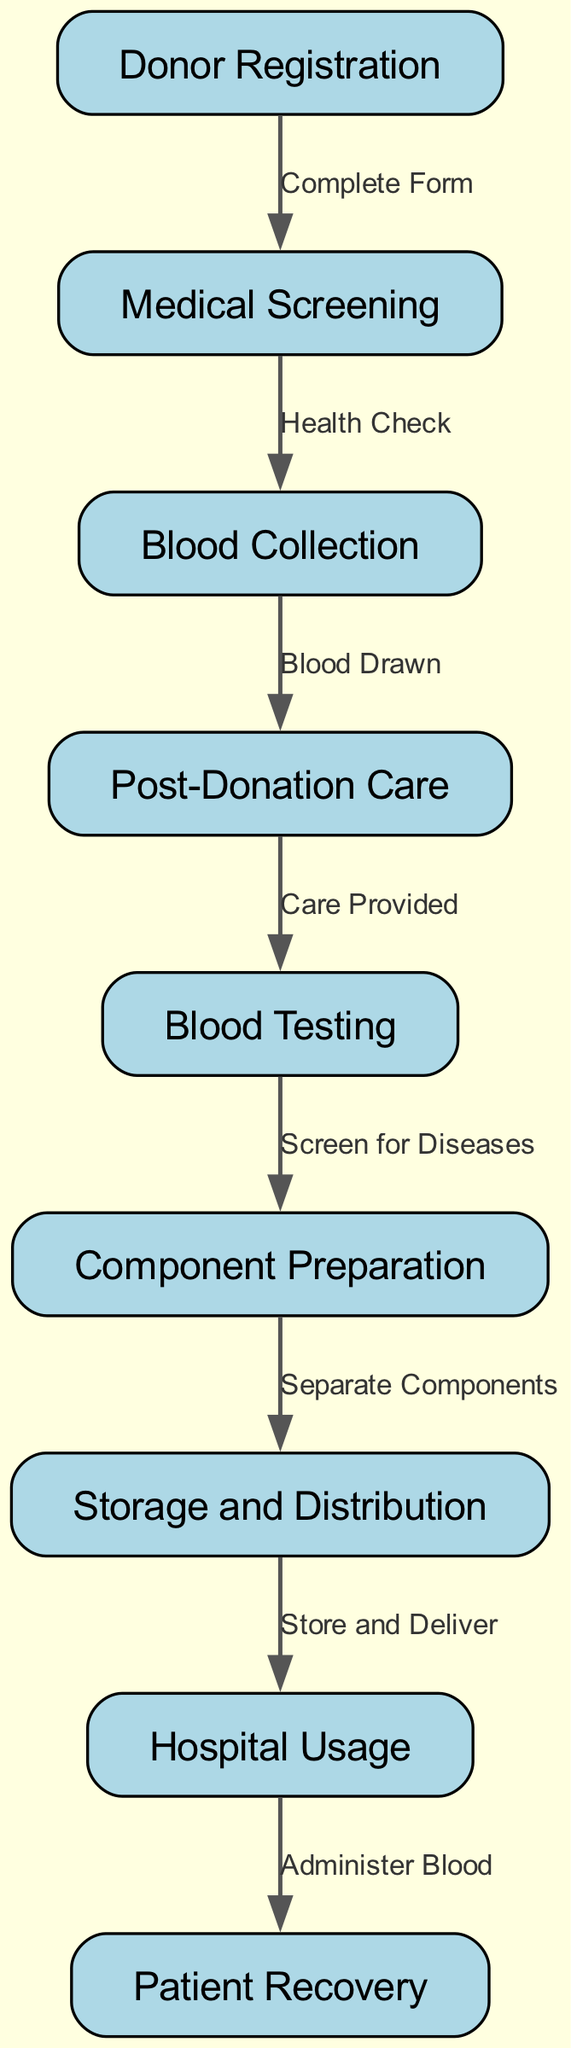How many nodes are present in the diagram? The diagram lists a total of 9 different nodes related to the blood donation process, which are the steps from donor registration to patient recovery.
Answer: 9 What step comes immediately after blood collection? According to the flowchart, after blood collection, the next step is post-donation care. This is a direct connection where the flow proceeds to providing care after the blood is drawn.
Answer: Post-Donation Care Which step involves screening for diseases? The diagram indicates that blood testing specifically includes the step where blood is screened for diseases. Thus, this step is directly associated with testing the collected blood samples.
Answer: Blood Testing How many edges represent the connections between nodes? By counting the edges that connect the different steps in the blood donation process, there are a total of 8 edges linking the nodes together, showing the flow from one step to the next.
Answer: 8 What is the label of the node that follows storage and distribution? The flowchart shows that the next step after storage and distribution is hospital usage, indicating that after storing blood components, they are delivered to hospitals for use.
Answer: Hospital Usage What is the final step in the blood donation process? The flowchart concludes with patient recovery as the last step, illustrating that this is the ultimate goal of the blood donation process—supporting patients in their recovery through delivered blood.
Answer: Patient Recovery What connection describes the action taken after post-donation care? The action taken after post-donation care is represented by the edge labeled "Care Provided" leading to blood testing, indicating that after ensuring the donor's wellbeing, the next phase is to test the donated blood.
Answer: Blood Testing Which step involves separating components? The diagram specifies that component preparation is responsible for separating blood components after they have been tested, indicating this is a critical step in processing the donated blood.
Answer: Component Preparation What is the relationship between donor registration and medical screening? The relationship is indicated by the label "Complete Form," which shows that donor registration is the initial step that enables the subsequent medical screening process.
Answer: Complete Form 